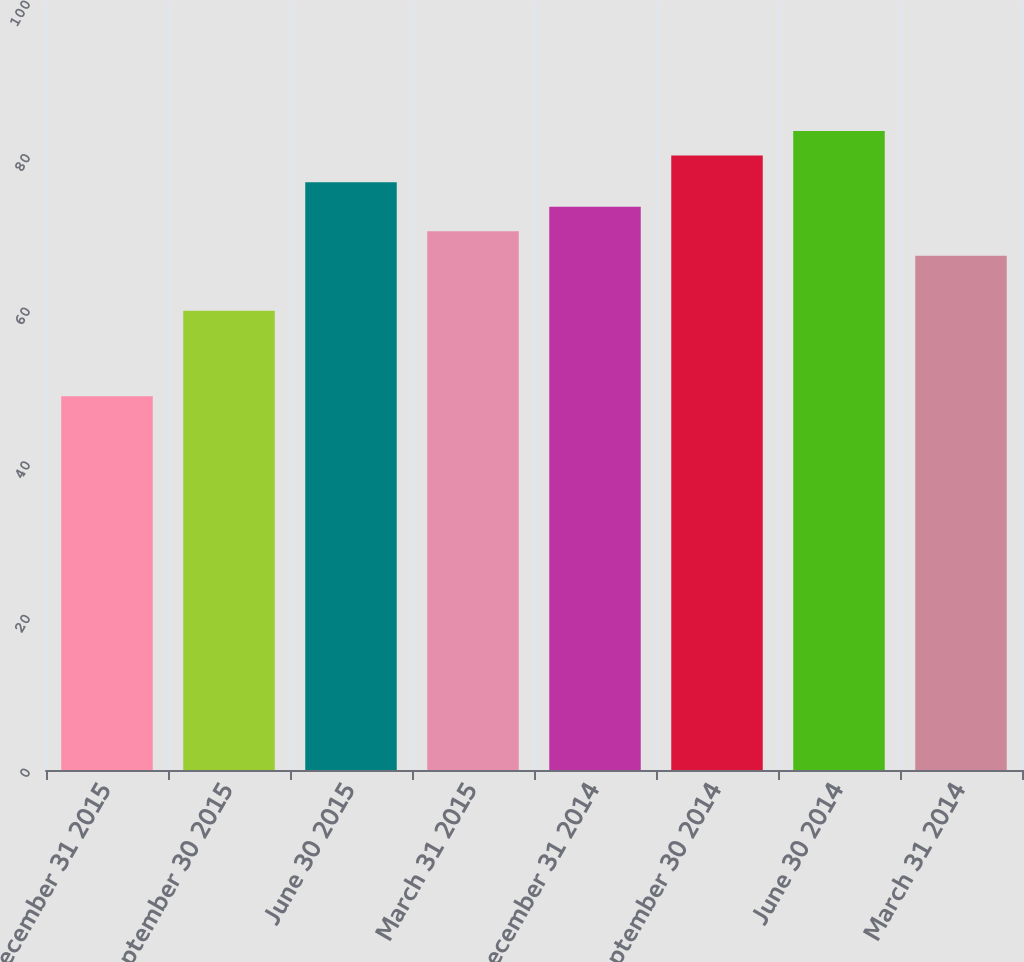<chart> <loc_0><loc_0><loc_500><loc_500><bar_chart><fcel>December 31 2015<fcel>September 30 2015<fcel>June 30 2015<fcel>March 31 2015<fcel>December 31 2014<fcel>September 30 2014<fcel>June 30 2014<fcel>March 31 2014<nl><fcel>48.68<fcel>59.8<fcel>76.52<fcel>70.14<fcel>73.33<fcel>80.01<fcel>83.2<fcel>66.95<nl></chart> 